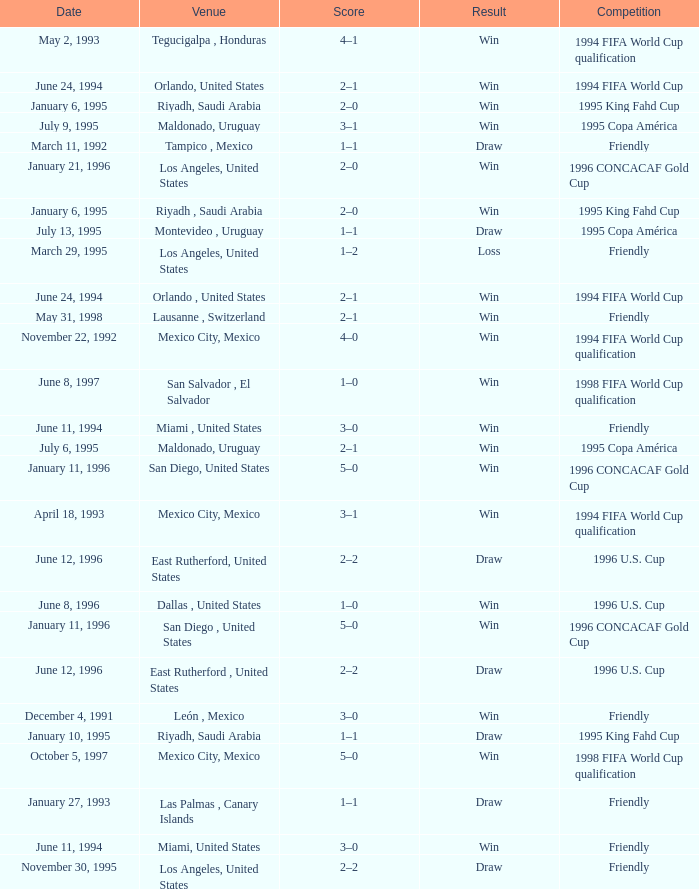What is Competition, when Date is "January 11, 1996", when Venue is "San Diego , United States"? 1996 CONCACAF Gold Cup, 1996 CONCACAF Gold Cup. 